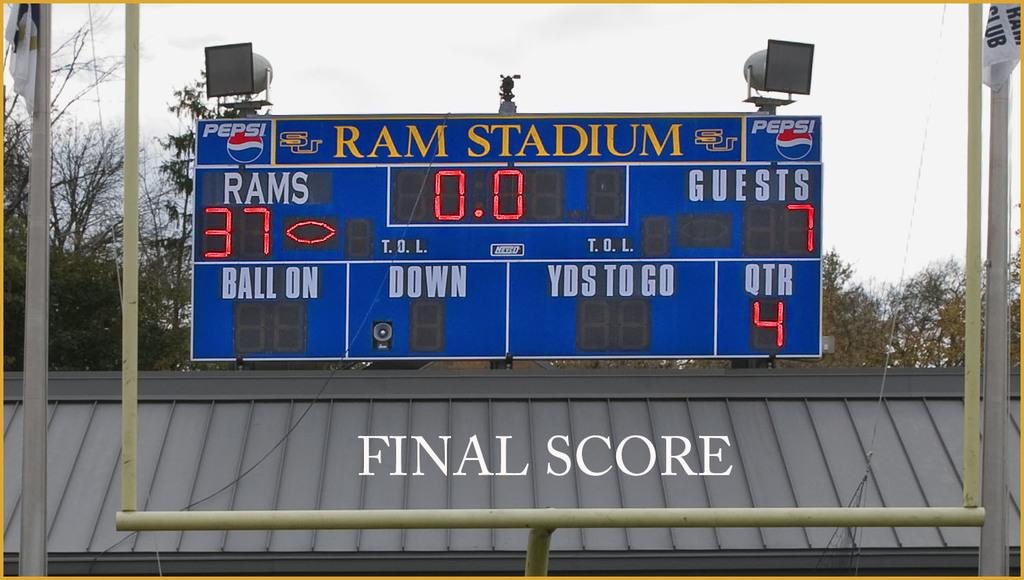<image>
Describe the image concisely. An outdoor digital display board with Ram Stadium on it. 